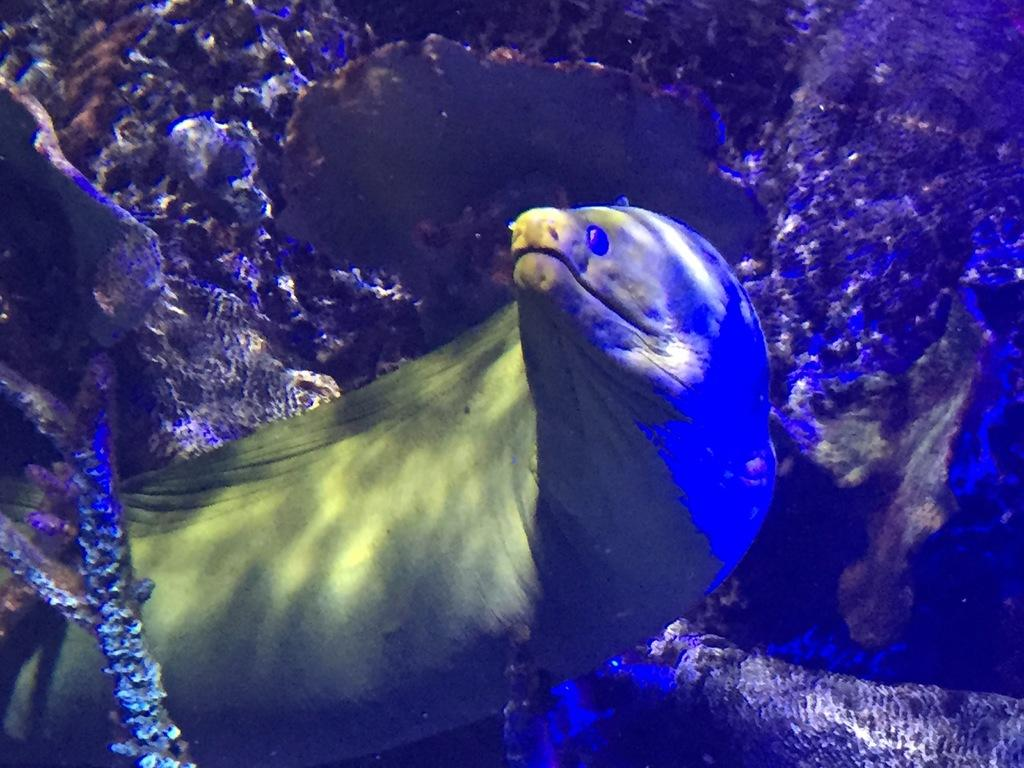What type of animal is in the image? The animal in the image is green in color. Can you describe the overall color scheme of the image? The image has a blue tint. How does the animal's disgust factor contribute to the image? The animal in the image does not display any emotions, and there is no indication of disgust. 